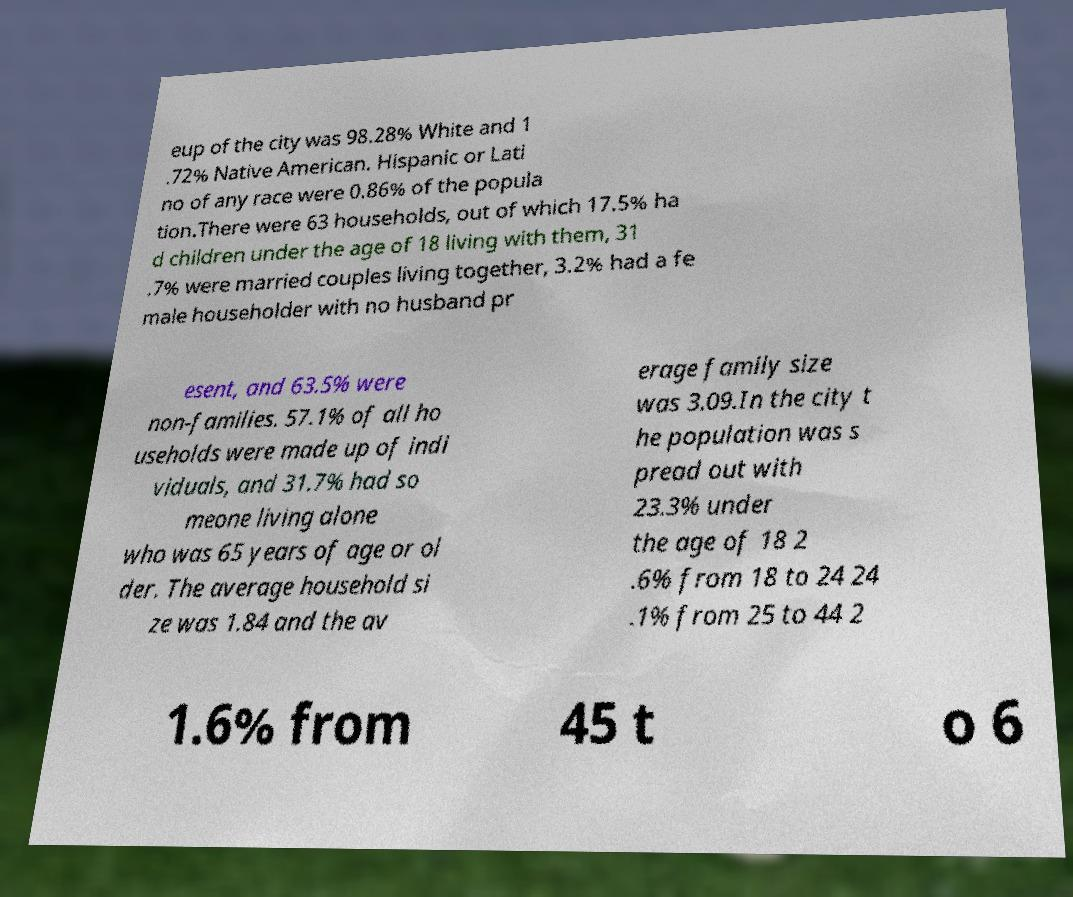Could you extract and type out the text from this image? eup of the city was 98.28% White and 1 .72% Native American. Hispanic or Lati no of any race were 0.86% of the popula tion.There were 63 households, out of which 17.5% ha d children under the age of 18 living with them, 31 .7% were married couples living together, 3.2% had a fe male householder with no husband pr esent, and 63.5% were non-families. 57.1% of all ho useholds were made up of indi viduals, and 31.7% had so meone living alone who was 65 years of age or ol der. The average household si ze was 1.84 and the av erage family size was 3.09.In the city t he population was s pread out with 23.3% under the age of 18 2 .6% from 18 to 24 24 .1% from 25 to 44 2 1.6% from 45 t o 6 